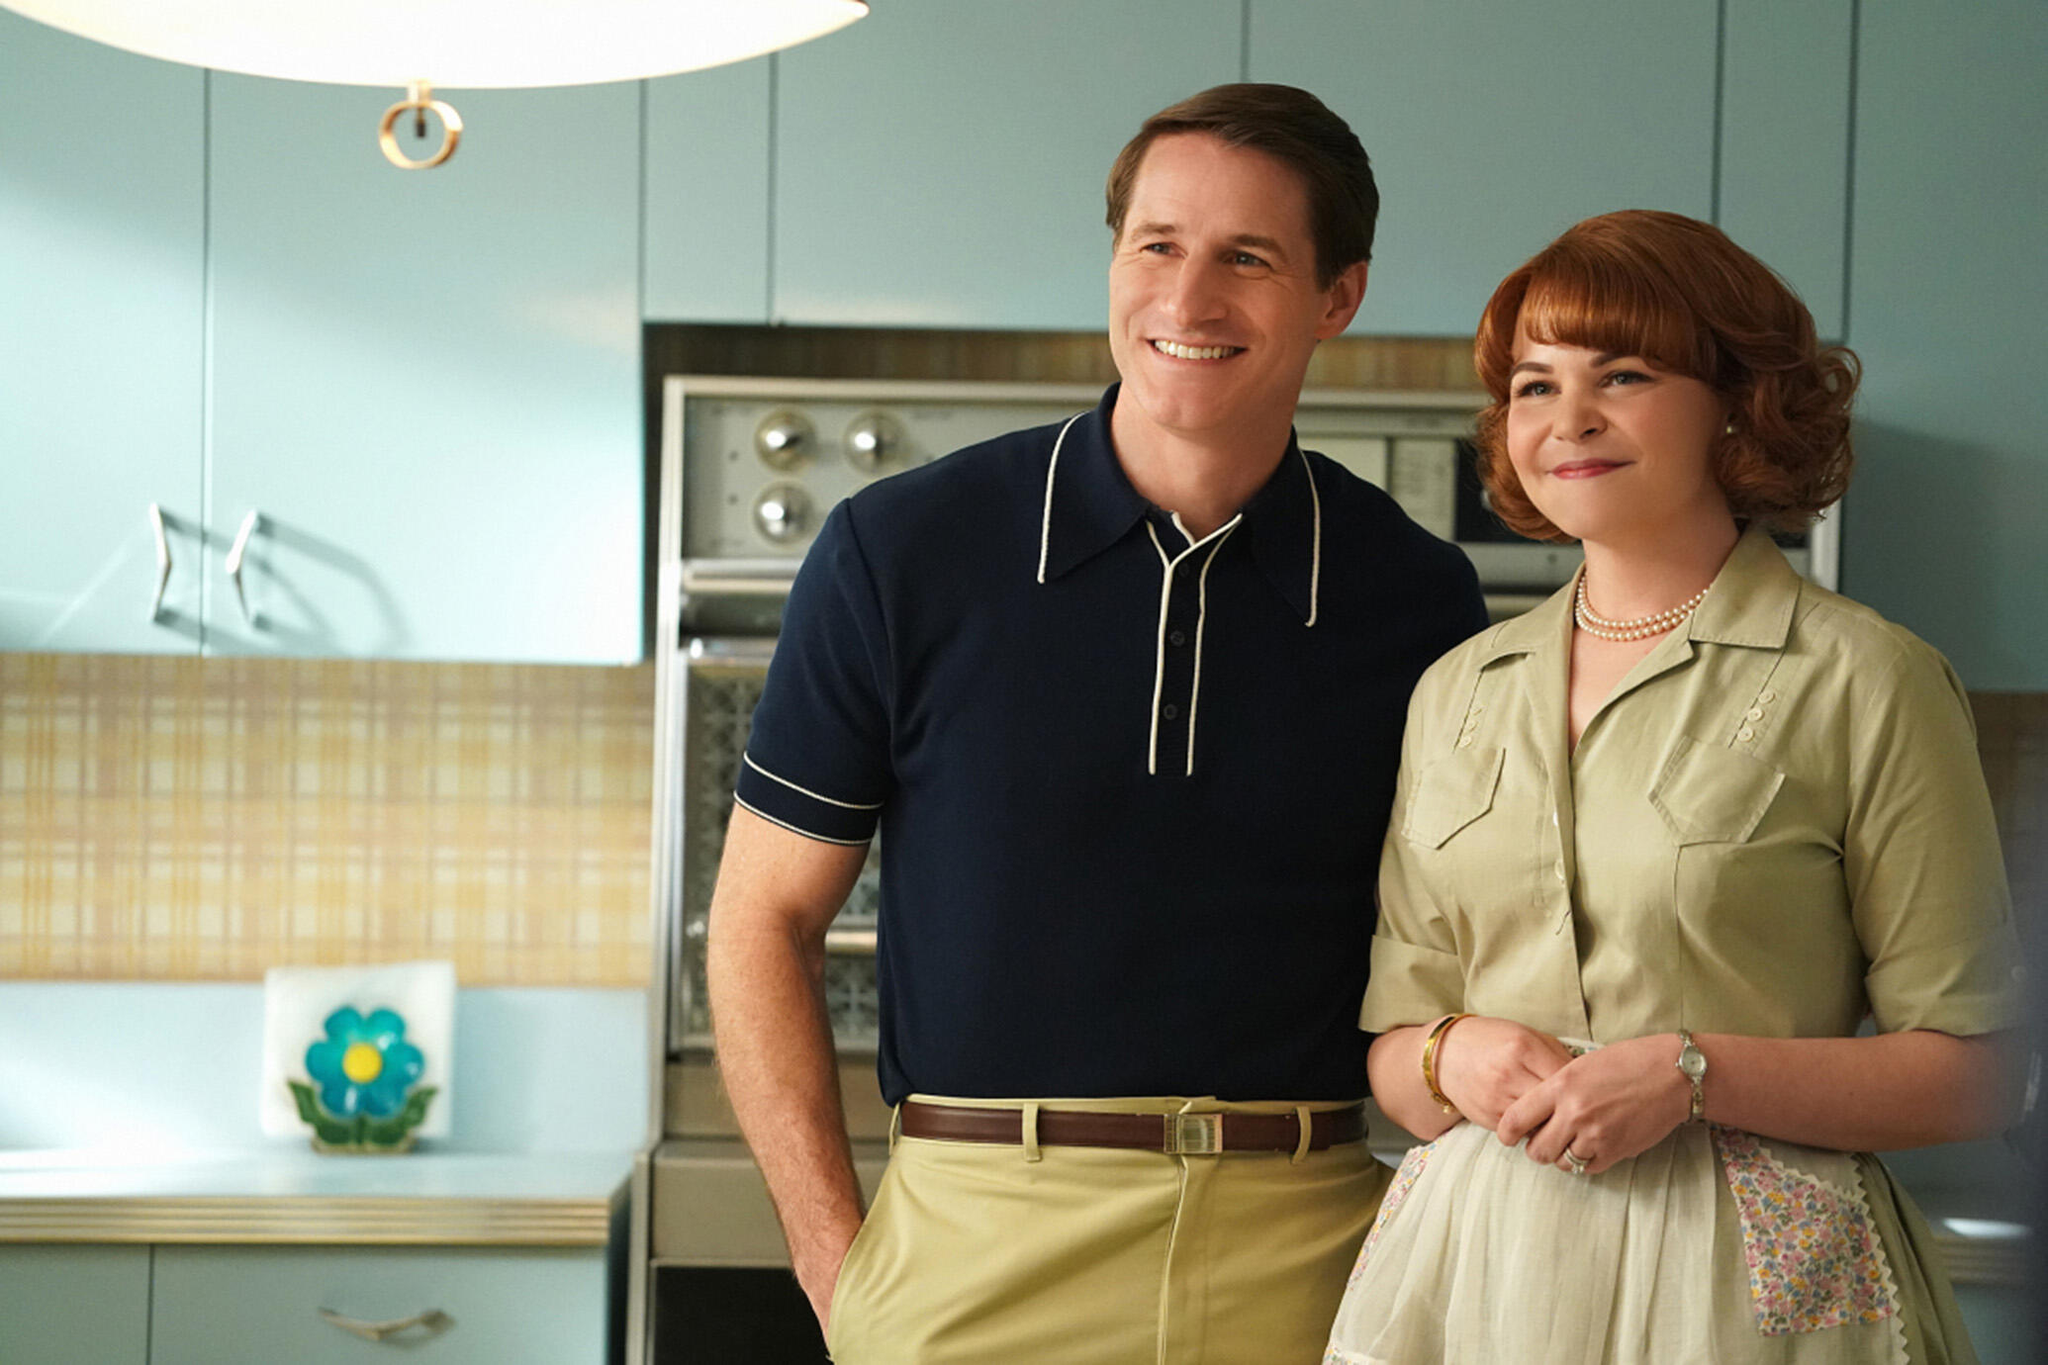What era do you think this kitchen represents? This kitchen predominantly reflects the design and aesthetic styles of the 1950s or early 1960s. The pastel colors combined with the geometric patterns on the curtains and the style of the appliances are characteristic of that era, emphasizing a blend of simplicity and functionality popular in post-war American homes. What can we infer about the characters based on their clothing? The characters' clothing suggests a casual yet polished look associated with mid-century modern style. The male's polo shirt and slacks suggest a leisurely yet tidy appearance, likely indicating a comfortable middle-class lifestyle. The female's attire, including her dress and apron with floral patterns, conveys a homey yet stylish image, often idealized in representations of women from this period in domestic settings. 